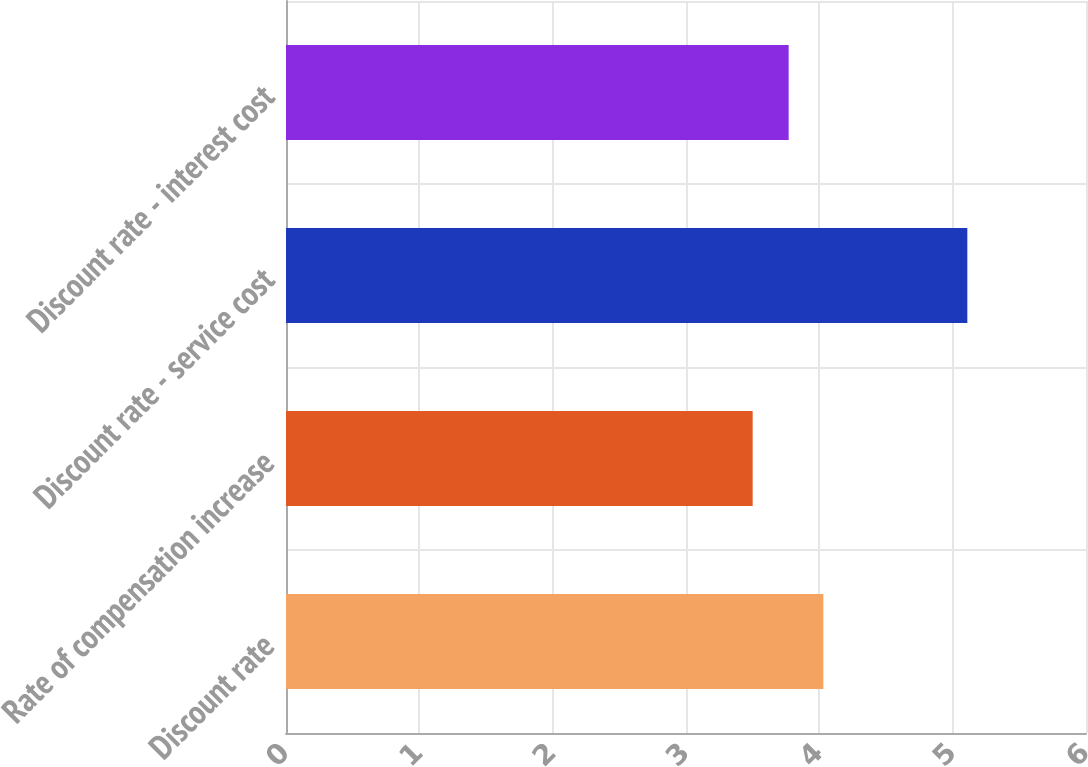Convert chart. <chart><loc_0><loc_0><loc_500><loc_500><bar_chart><fcel>Discount rate<fcel>Rate of compensation increase<fcel>Discount rate - service cost<fcel>Discount rate - interest cost<nl><fcel>4.03<fcel>3.5<fcel>5.11<fcel>3.77<nl></chart> 